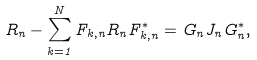<formula> <loc_0><loc_0><loc_500><loc_500>R _ { n } - \sum _ { k = 1 } ^ { N } F _ { k , n } R _ { n } F ^ { * } _ { k , n } = G _ { n } J _ { n } G ^ { * } _ { n } ,</formula> 